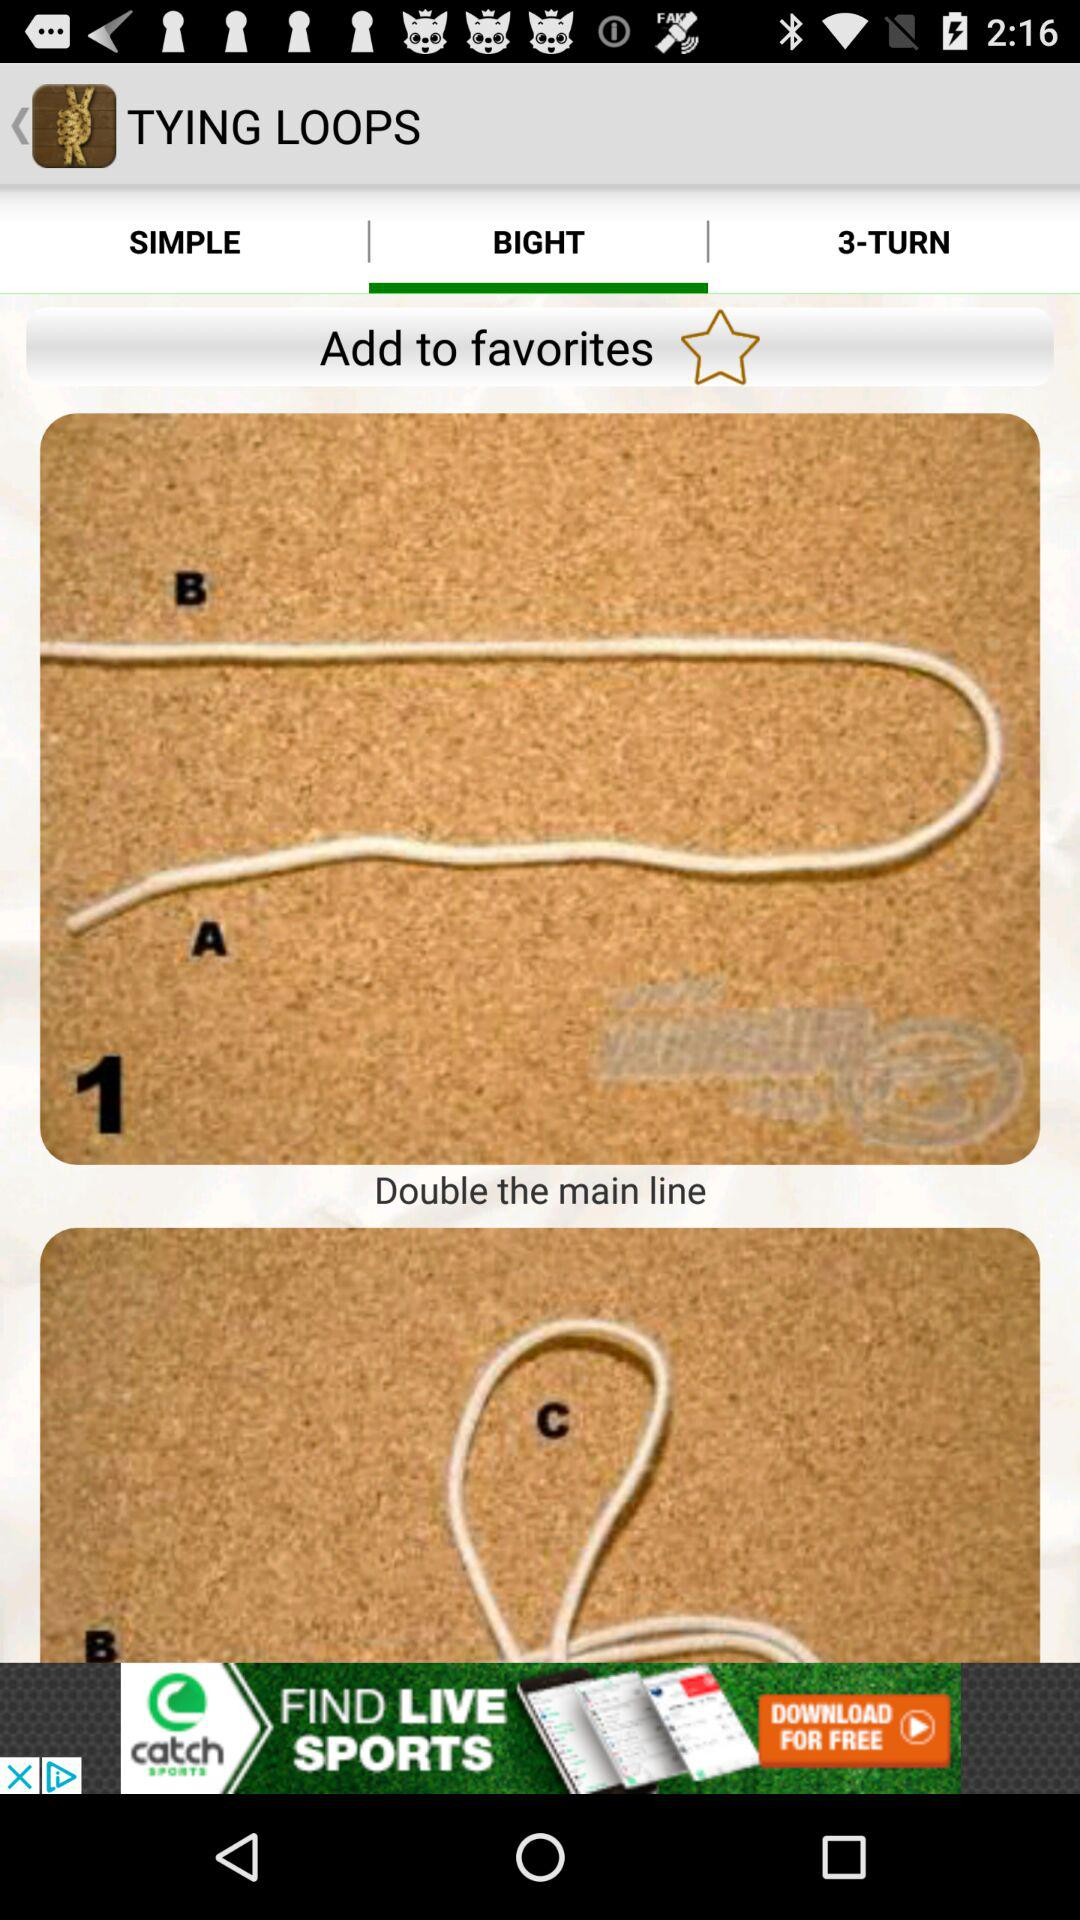Which option has been selected? The option that has been selected is "BIGHT". 